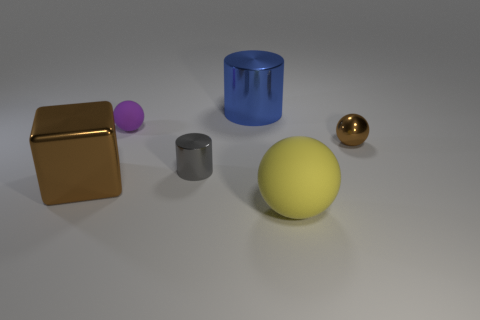Add 3 big yellow matte balls. How many objects exist? 9 Subtract all cylinders. How many objects are left? 4 Subtract 0 yellow cubes. How many objects are left? 6 Subtract all large cubes. Subtract all big blue blocks. How many objects are left? 5 Add 4 balls. How many balls are left? 7 Add 1 green rubber objects. How many green rubber objects exist? 1 